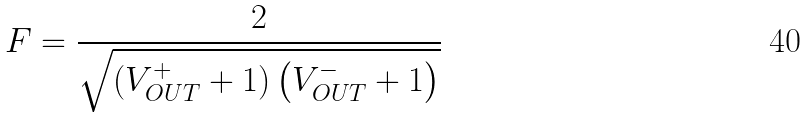Convert formula to latex. <formula><loc_0><loc_0><loc_500><loc_500>F = \frac { 2 } { \sqrt { \left ( V ^ { + } _ { O U T } + 1 \right ) \left ( V ^ { - } _ { O U T } + 1 \right ) } }</formula> 